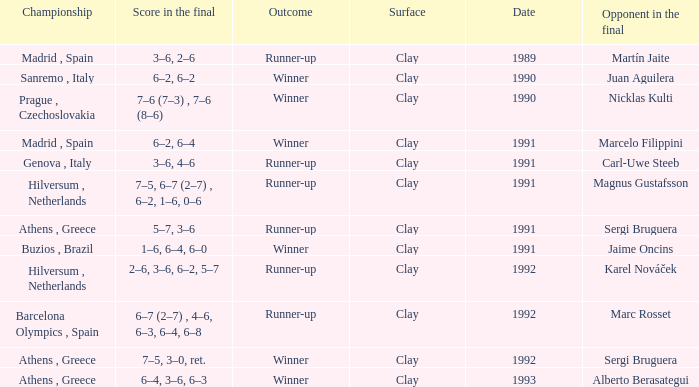Would you mind parsing the complete table? {'header': ['Championship', 'Score in the final', 'Outcome', 'Surface', 'Date', 'Opponent in the final'], 'rows': [['Madrid , Spain', '3–6, 2–6', 'Runner-up', 'Clay', '1989', 'Martín Jaite'], ['Sanremo , Italy', '6–2, 6–2', 'Winner', 'Clay', '1990', 'Juan Aguilera'], ['Prague , Czechoslovakia', '7–6 (7–3) , 7–6 (8–6)', 'Winner', 'Clay', '1990', 'Nicklas Kulti'], ['Madrid , Spain', '6–2, 6–4', 'Winner', 'Clay', '1991', 'Marcelo Filippini'], ['Genova , Italy', '3–6, 4–6', 'Runner-up', 'Clay', '1991', 'Carl-Uwe Steeb'], ['Hilversum , Netherlands', '7–5, 6–7 (2–7) , 6–2, 1–6, 0–6', 'Runner-up', 'Clay', '1991', 'Magnus Gustafsson'], ['Athens , Greece', '5–7, 3–6', 'Runner-up', 'Clay', '1991', 'Sergi Bruguera'], ['Buzios , Brazil', '1–6, 6–4, 6–0', 'Winner', 'Clay', '1991', 'Jaime Oncins'], ['Hilversum , Netherlands', '2–6, 3–6, 6–2, 5–7', 'Runner-up', 'Clay', '1992', 'Karel Nováček'], ['Barcelona Olympics , Spain', '6–7 (2–7) , 4–6, 6–3, 6–4, 6–8', 'Runner-up', 'Clay', '1992', 'Marc Rosset'], ['Athens , Greece', '7–5, 3–0, ret.', 'Winner', 'Clay', '1992', 'Sergi Bruguera'], ['Athens , Greece', '6–4, 3–6, 6–3', 'Winner', 'Clay', '1993', 'Alberto Berasategui']]} What is Score In The Final, when Championship is "Athens , Greece", and when Outcome is "Winner"? 7–5, 3–0, ret., 6–4, 3–6, 6–3. 